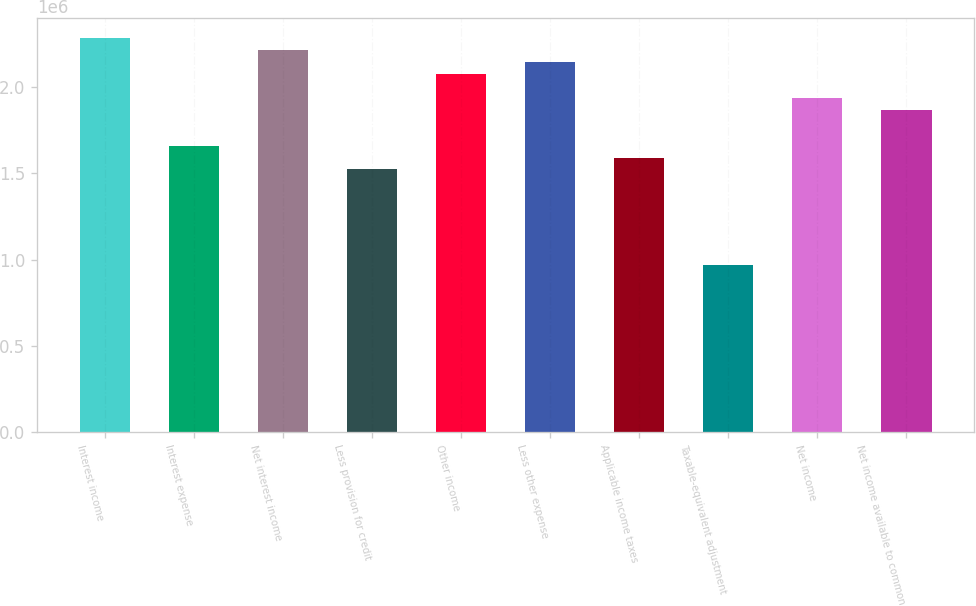<chart> <loc_0><loc_0><loc_500><loc_500><bar_chart><fcel>Interest income<fcel>Interest expense<fcel>Net interest income<fcel>Less provision for credit<fcel>Other income<fcel>Less other expense<fcel>Applicable income taxes<fcel>Taxable-equivalent adjustment<fcel>Net income<fcel>Net income available to common<nl><fcel>2.28282e+06<fcel>1.66024e+06<fcel>2.21365e+06<fcel>1.52188e+06<fcel>2.07529e+06<fcel>2.14447e+06<fcel>1.59106e+06<fcel>968471<fcel>1.93694e+06<fcel>1.86776e+06<nl></chart> 